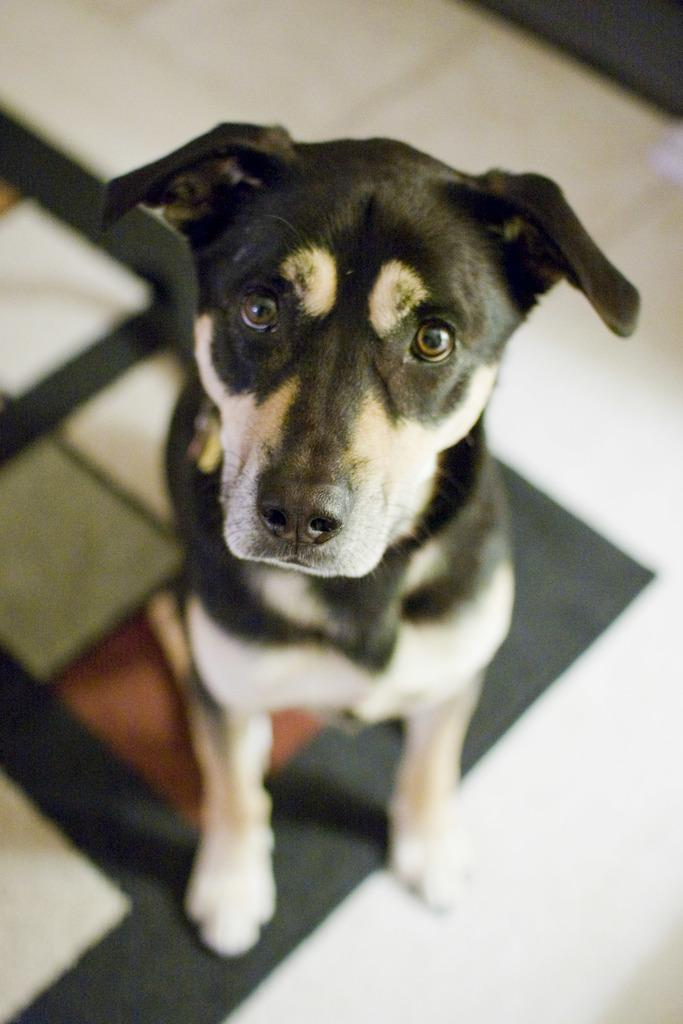What type of animal is in the image? There is a dog in the image. What colors can be seen on the dog? The dog is black and white in color. Where is the dog located in the image? The dog is in the middle of the image. What is visible behind the dog in the image? There is a floor visible in the background of the image. What type of fruit is the dog eating in the image? There is no fruit present in the image, and the dog is not eating anything. 